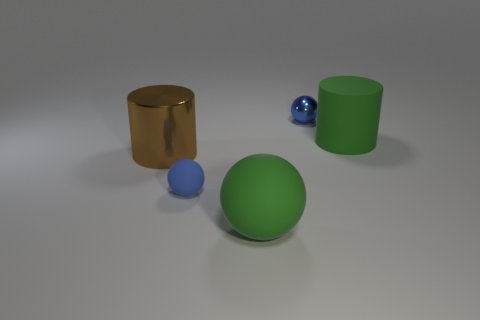Add 3 big red matte cubes. How many objects exist? 8 Subtract all spheres. How many objects are left? 2 Subtract all small blue rubber balls. Subtract all brown things. How many objects are left? 3 Add 2 tiny rubber balls. How many tiny rubber balls are left? 3 Add 2 tiny metallic cylinders. How many tiny metallic cylinders exist? 2 Subtract 0 red spheres. How many objects are left? 5 